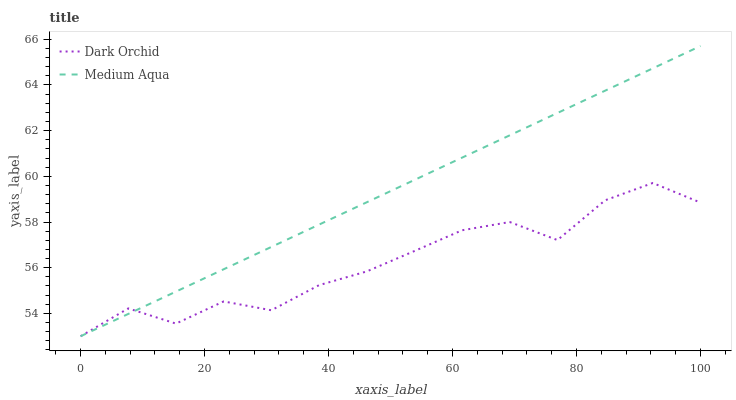Does Dark Orchid have the minimum area under the curve?
Answer yes or no. Yes. Does Medium Aqua have the maximum area under the curve?
Answer yes or no. Yes. Does Dark Orchid have the maximum area under the curve?
Answer yes or no. No. Is Medium Aqua the smoothest?
Answer yes or no. Yes. Is Dark Orchid the roughest?
Answer yes or no. Yes. Is Dark Orchid the smoothest?
Answer yes or no. No. Does Medium Aqua have the lowest value?
Answer yes or no. Yes. Does Medium Aqua have the highest value?
Answer yes or no. Yes. Does Dark Orchid have the highest value?
Answer yes or no. No. Does Dark Orchid intersect Medium Aqua?
Answer yes or no. Yes. Is Dark Orchid less than Medium Aqua?
Answer yes or no. No. Is Dark Orchid greater than Medium Aqua?
Answer yes or no. No. 